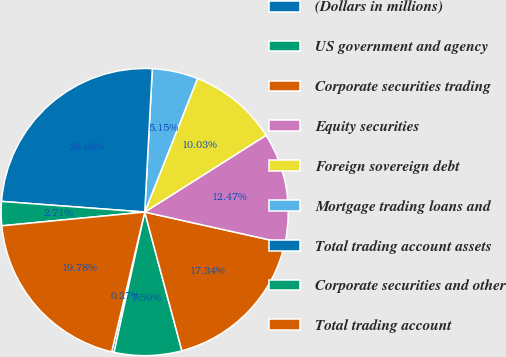Convert chart. <chart><loc_0><loc_0><loc_500><loc_500><pie_chart><fcel>(Dollars in millions)<fcel>US government and agency<fcel>Corporate securities trading<fcel>Equity securities<fcel>Foreign sovereign debt<fcel>Mortgage trading loans and<fcel>Total trading account assets<fcel>Corporate securities and other<fcel>Total trading account<nl><fcel>0.27%<fcel>7.59%<fcel>17.34%<fcel>12.47%<fcel>10.03%<fcel>5.15%<fcel>24.66%<fcel>2.71%<fcel>19.78%<nl></chart> 